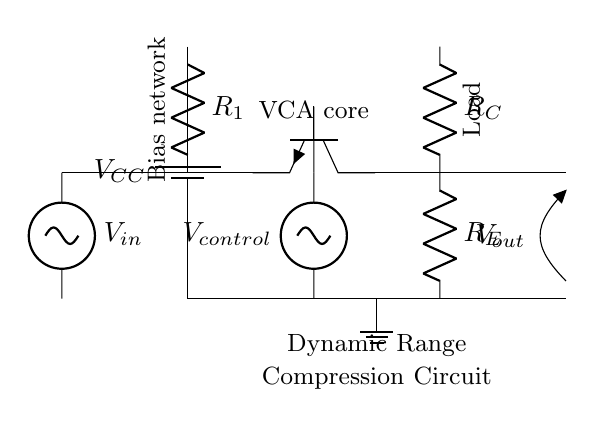What is the supply voltage in this circuit? The supply voltage is represented by the battery symbol labeled V_CC, which typically indicates the positive voltage supply for the circuit. Since no specific value is given, we deduce it from the circuit design context.
Answer: V_CC What component controls the gain of the amplifier? The gain of the amplifier is primarily controlled by the variable resistor in the circuit, which is implicitly represented as the transistor's function alongside the control voltage V_control. The configuration of the transistor and resistors together determine the dynamic range compression effect.
Answer: V_control How many resistors are present in the circuit? There are three resistors labeled R_1, R_C, and R_E, which are added to the circuit for biasing and load purposes.
Answer: 3 What type of transistor is used in this circuit? The circuit uses an NPN transistor, which is indicated by the symbol Tnpn in the diagram. It is used to amplify the input signal in the voltage-controlled amplifier configuration.
Answer: NPN What is the purpose of the control voltage? The control voltage, labeled V_control, modulates the operation of the amplifier, specifically affecting the transistor's biasing and thereby influencing the gain and dynamic range compression applied to the input signal.
Answer: Dynamic range compression Where is the output voltage taken from? The output voltage, labeled V_out, is taken from the collector terminal of the transistor, which is connected to the load represented by resistor R_C in the circuit.
Answer: Collector of the transistor 